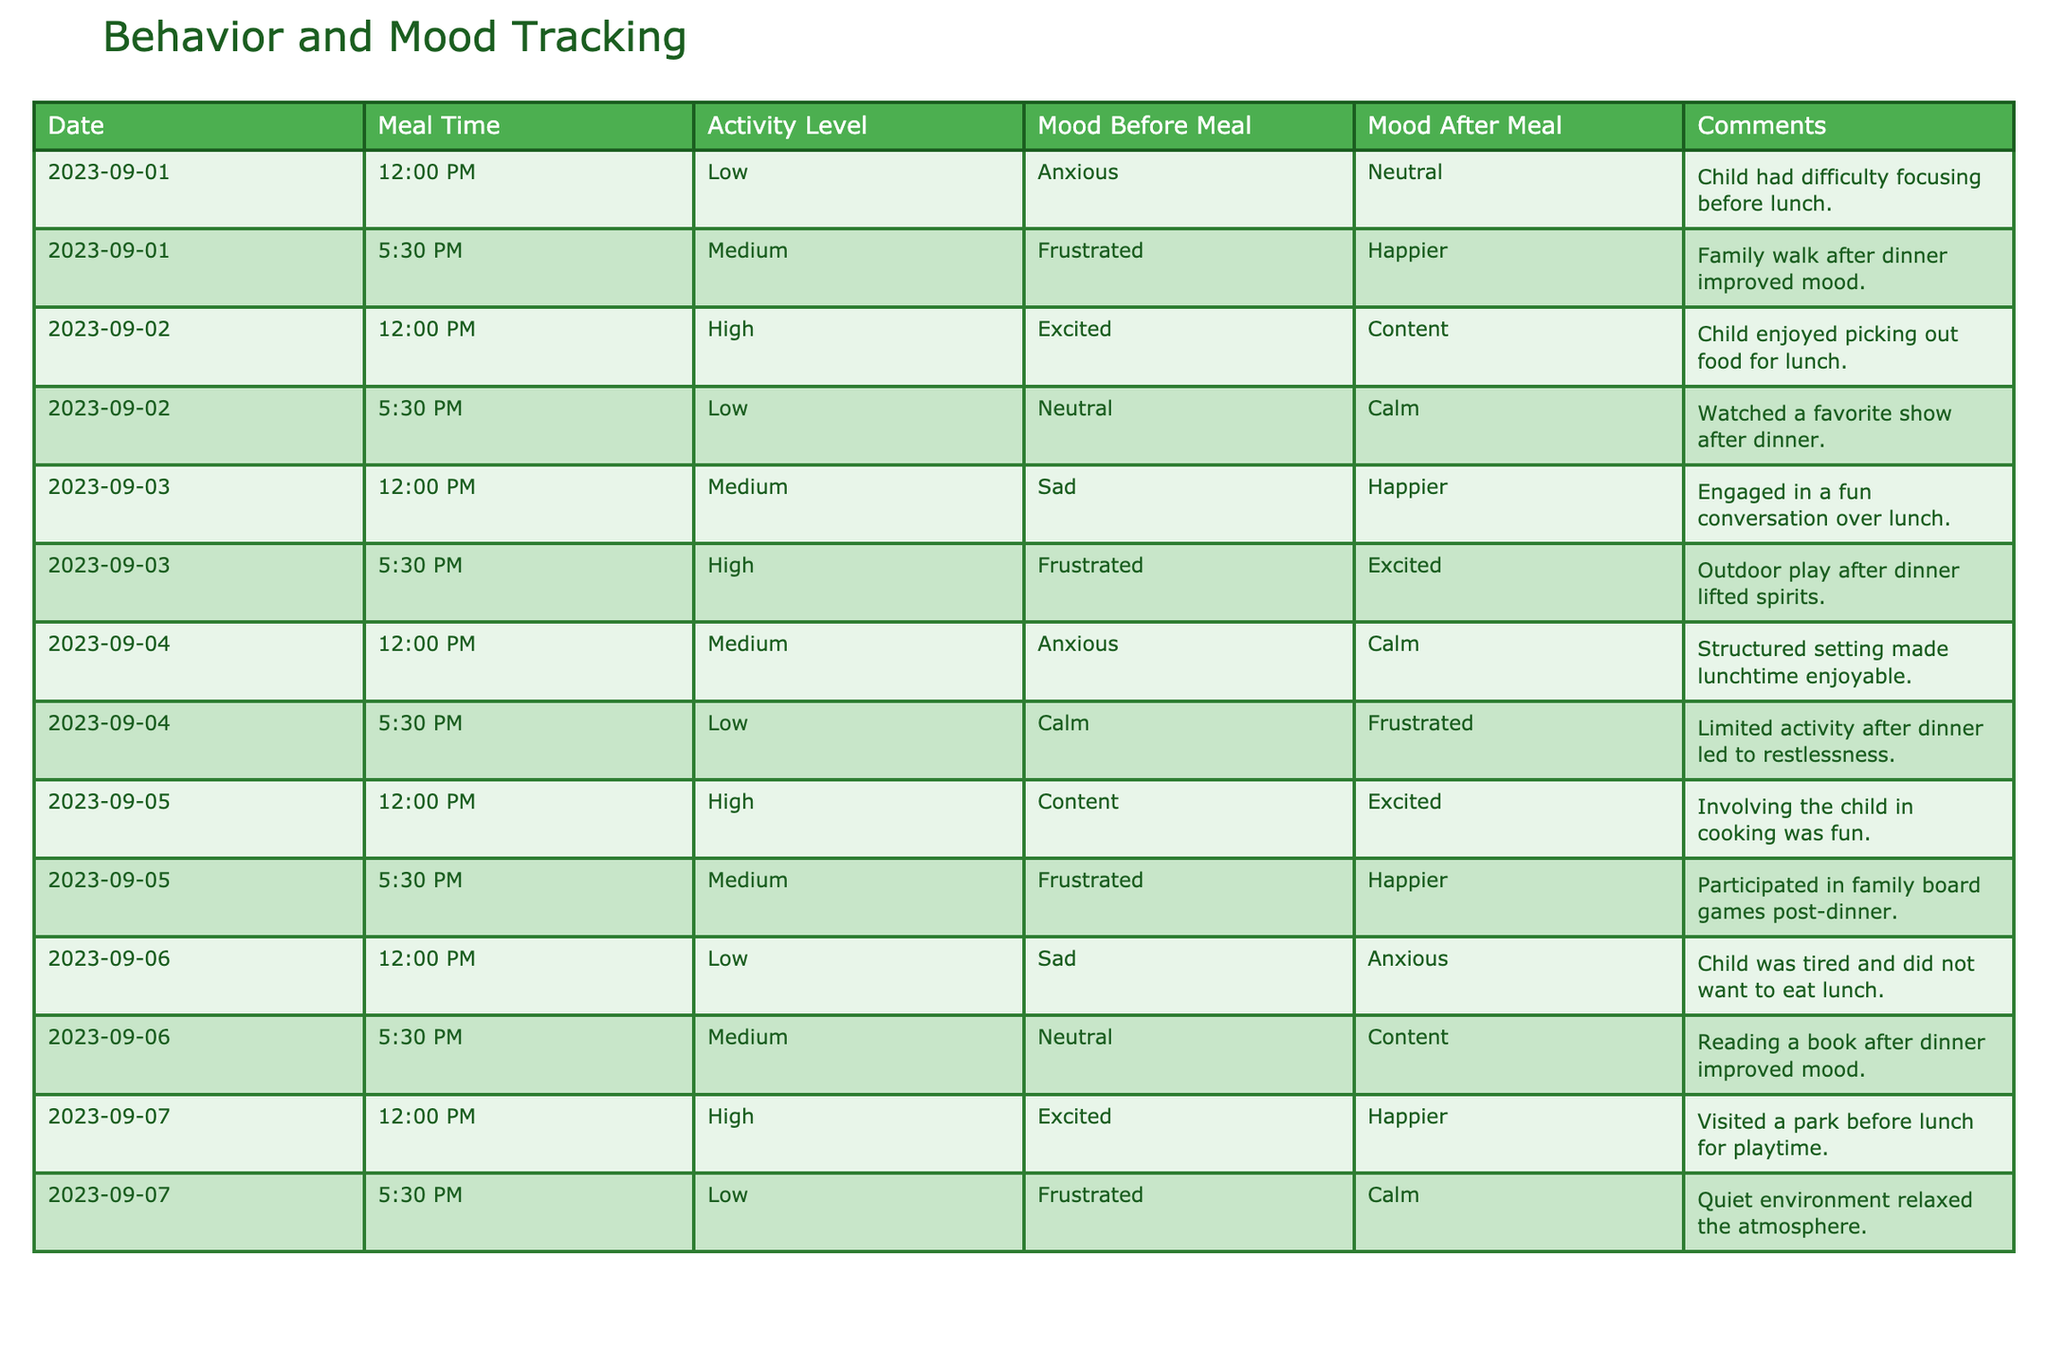What was the mood before the meal on September 1st at 12:00 PM? The table shows that on September 1st at 12:00 PM, the mood before the meal was "Anxious."
Answer: Anxious How many times was the mood described as "Frustrated" before meals? There are 3 instances in the table where the mood before meals is "Frustrated": on September 1st at 5:30 PM, September 3rd at 5:30 PM, and September 6th at 12:00 PM.
Answer: 3 What is the average activity level (Low, Medium, High) for the meals before the 5:30 PM time slot? The meals before the 5:30 PM time slot show activity levels of Medium (twice), Low (twice), and High (twice). Therefore, there are 2 Medium (2) + 2 Low (1) + 2 High (2) = 6 data points. The average on a scale of Low=1, Medium=2, High=3 is (2*2 + 2*1 + 2*3) / 6 = 2 = Medium.
Answer: Medium Was the mood after meals more often described as "Happier" or "Calm"? To determine the answer, we count the occurrences: "Happier" appears on September 1st at 5:30 PM, September 3rd at 12:00 PM, September 3rd at 5:30 PM, and September 5th at 5:30 PM (4 times), while "Calm" appears on September 4th at 5:30 PM, September 6th at 5:30 PM, and September 7th at 5:30 PM (3 times). Since Happier occurs 4 times while Calm occurs 3 times, the answer is Happier.
Answer: Happier Which meal had the highest activity level and what was the mood before and after that meal? The highest activity level, "High," occurs on September 2nd at 12:00 PM and September 7th at 12:00 PM. The mood before the meal on September 2nd is "Excited," and after the meal, it is "Content." For September 7th, the mood before is "Excited," and after is "Happier." Since both have the same activity level but the first instance holds precedence, the first instance is selected for the answer: Mood before is "Excited," Mood after is "Content."
Answer: Excited, Content What is the overall trend of mood changes after each meal compared to before? By comparing the moods before and after meals for all entries, it appears that out of 12 meals, the mood improved after meals in 7 instances (e.g., from "Frustrated" to "Happier"), remained the same in 3 instances (e.g., from "Neutral" to "Calm"), and got worse in only 2 instances (e.g., from "Sad" to "Anxious"). Therefore, the overall trend is an improvement in mood after meals.
Answer: Improvement 